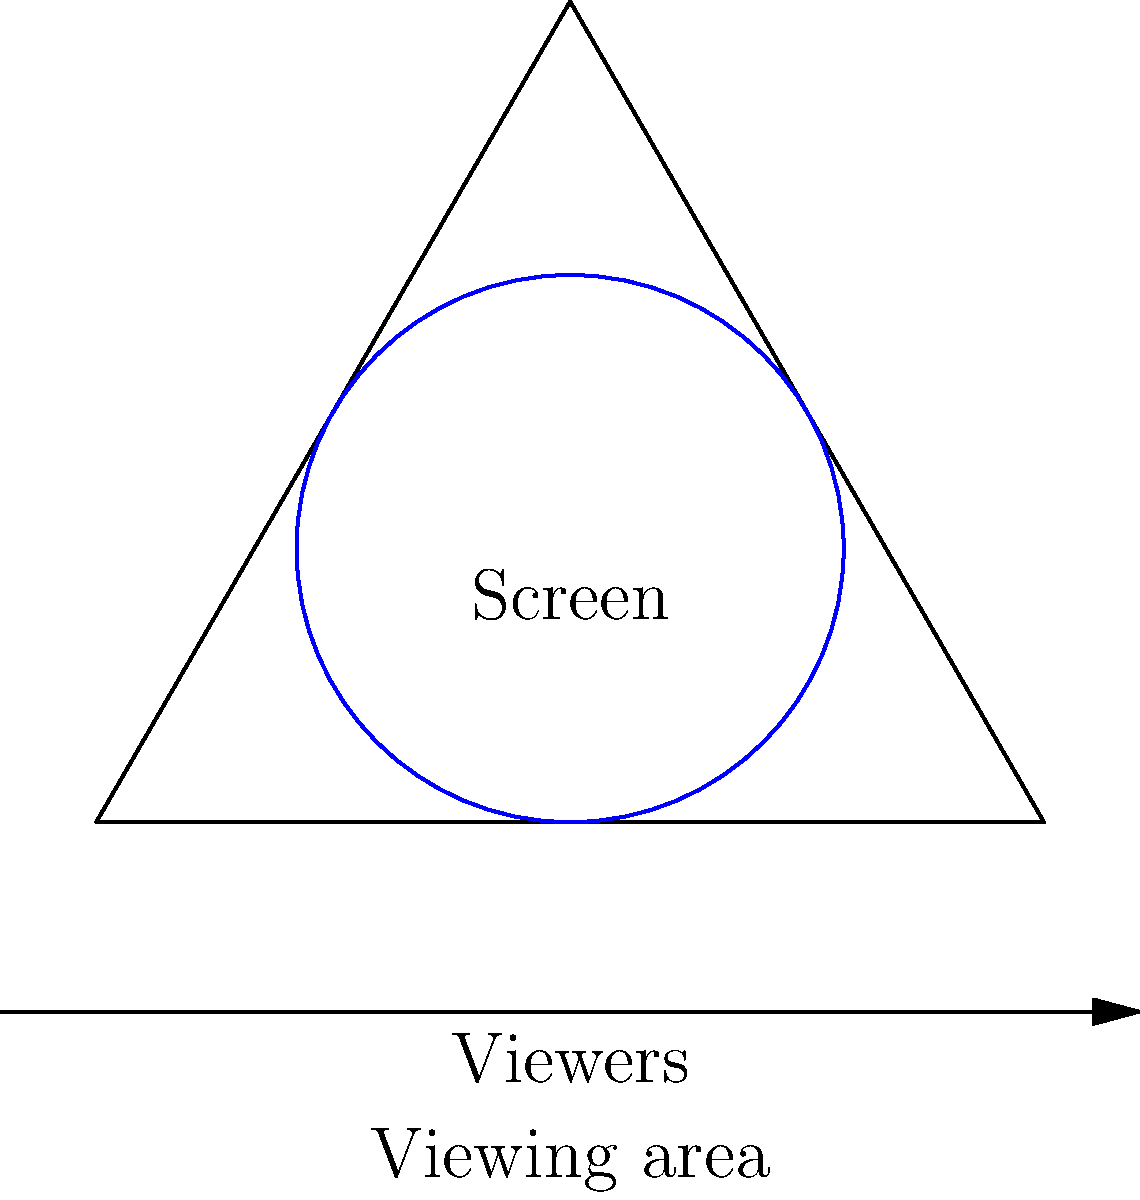For a tennis court viewing screen, which shape would provide the best visibility from multiple angles in your café's viewing area? To determine the most efficient shape for a tennis court viewing screen, we need to consider the following factors:

1. Visibility from multiple angles: The screen should be visible from various positions in the viewing area.
2. Maximizing screen area: A larger screen area allows for better visibility of the tennis match.
3. Minimizing distortion: The shape should minimize visual distortion for viewers at different angles.

Let's analyze the options:

1. Rectangle: While common, rectangles may have visibility issues from extreme angles.
2. Trapezoid: Better than rectangles for side viewing but still not optimal.
3. Circle: Provides equal visibility from all angles but may not maximize screen area efficiently.
4. Ellipse: Can offer a good compromise but may have some distortion issues.
5. Curved screen (arc): This shape can provide the best solution.

The curved screen (arc) shape is optimal because:

a) It follows the natural curve of human peripheral vision.
b) It maximizes the visible screen area from multiple angles.
c) It minimizes distortion for viewers at different positions.
d) It can be designed to match the viewing area's shape and size.

In the diagram, the blue arc represents the curved screen, which is positioned to face the viewing area. This configuration ensures that all viewers in the café can see the screen clearly, regardless of their position.
Answer: Curved screen (arc) 